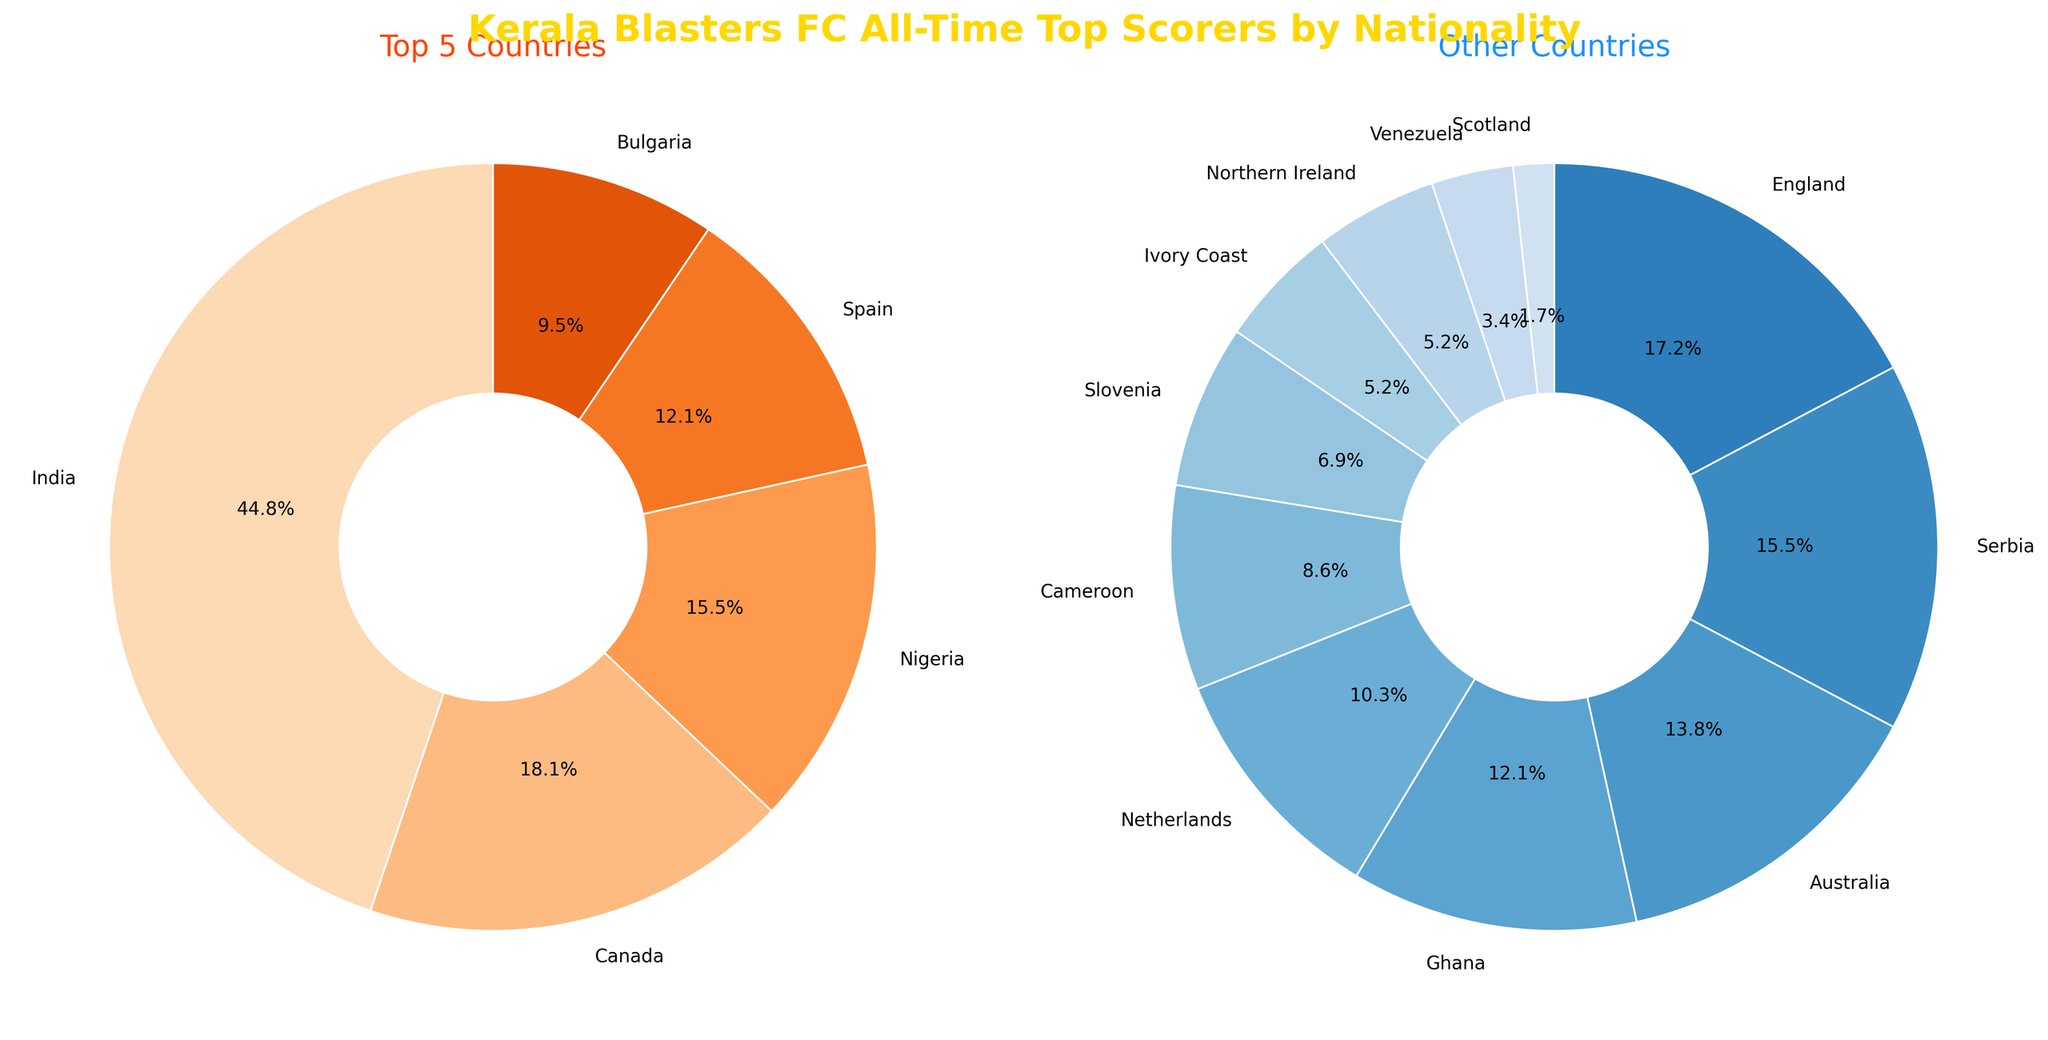What percentage of total goals do the top 5 countries contribute? The top 5 countries are India, Canada, Nigeria, Spain, and Bulgaria. By looking at the chart, their percentages are labeled directly. Summing these percentages gives the total contribution of the top 5 countries. Percentages are 39.4% (India) + 15.9% (Canada) + 13.6% (Nigeria) + 10.6% (Spain) + 8.3% (Bulgaria) = 87.8%.
Answer: 87.8% How many more goals did Indian players score compared to Nigerian players? According to the chart, Indian players scored 52 goals while Nigerian players scored 18 goals. The difference is 52 - 18 = 34 goals.
Answer: 34 Which country among the top 5 has the lowest goal count, and what is that count? Among the top 5 countries displayed in the first pie chart, Bulgaria has the lowest number of goals, which is 11.
Answer: Bulgaria, 11 What is the dominant color on the pie chart for non-top 5 countries? Looking at the second pie chart for the other countries, the dominant color appears to be various shades of blue.
Answer: Blue How do the total goals of the top 5 countries compare to the total goals of the rest? The total goals of the top 5 countries are obtained by summing their individual goals: 52 (India) + 21 (Canada) + 18 (Nigeria) + 14 (Spain) + 11 (Bulgaria) = 116 goals. The total goals of the rest are obtained by summing the goals of all other countries: 10 + 9 + 8 + 7 + 6 + 5 + 4 + 3 + 3 + 2 + 1 = 58 goals.
Answer: Top 5: 116, Rest: 58 Which pie chart has a more varied color scheme? The color scheme variety is determined by the range of different colors used in each pie chart. The second pie chart (other countries) uses a more varied color scheme with different shades of blue compared to the first one, which uses shades of orange.
Answer: Other Countries What is the combined percentage of goals scored by players from Spain and Serbia? According to the pie charts, Spain scores 10.6% and Serbia is part of the other countries chart. Adding these with Serbia found in rest chart, Spain (10.6%) + Serbia (5.2%) = 15.8%.
Answer: 15.8% How many countries have players that scored fewer than 5 goals? Referring to the list of other countries, there are Venezuela (2), Scotland (1), Northern Ireland (3), Ivory Coast (3), and Slovenia (4). That makes 5 countries.
Answer: 5 What is the visual difference in the wedge widths between the top scoring country in each chart? The wedge width of the highest scoring country (India) in the top 5 is wider and larger than the highest scoring in the rest (England), signifying more goals.
Answer: India wedge is wider than England Which two countries score exactly the same number of goals? From the chart, Northern Ireland and Ivory Coast both have 3 goals each.
Answer: Northern Ireland and Ivory Coast 